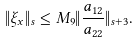<formula> <loc_0><loc_0><loc_500><loc_500>\| \xi _ { x } \| _ { s } \leq M _ { 9 } \| \frac { a _ { 1 2 } } { a _ { 2 2 } } \| _ { s + 3 } .</formula> 